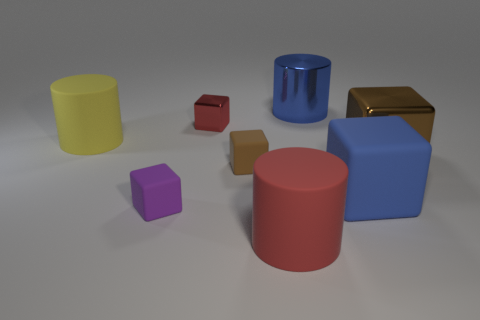Add 2 small blue things. How many objects exist? 10 Subtract all blue cubes. How many cubes are left? 4 Subtract all cyan cubes. How many purple cylinders are left? 0 Subtract all tiny brown matte objects. Subtract all yellow objects. How many objects are left? 6 Add 7 yellow matte cylinders. How many yellow matte cylinders are left? 8 Add 1 big green matte blocks. How many big green matte blocks exist? 1 Subtract all blue cylinders. How many cylinders are left? 2 Subtract 0 purple cylinders. How many objects are left? 8 Subtract all cubes. How many objects are left? 3 Subtract 1 blocks. How many blocks are left? 4 